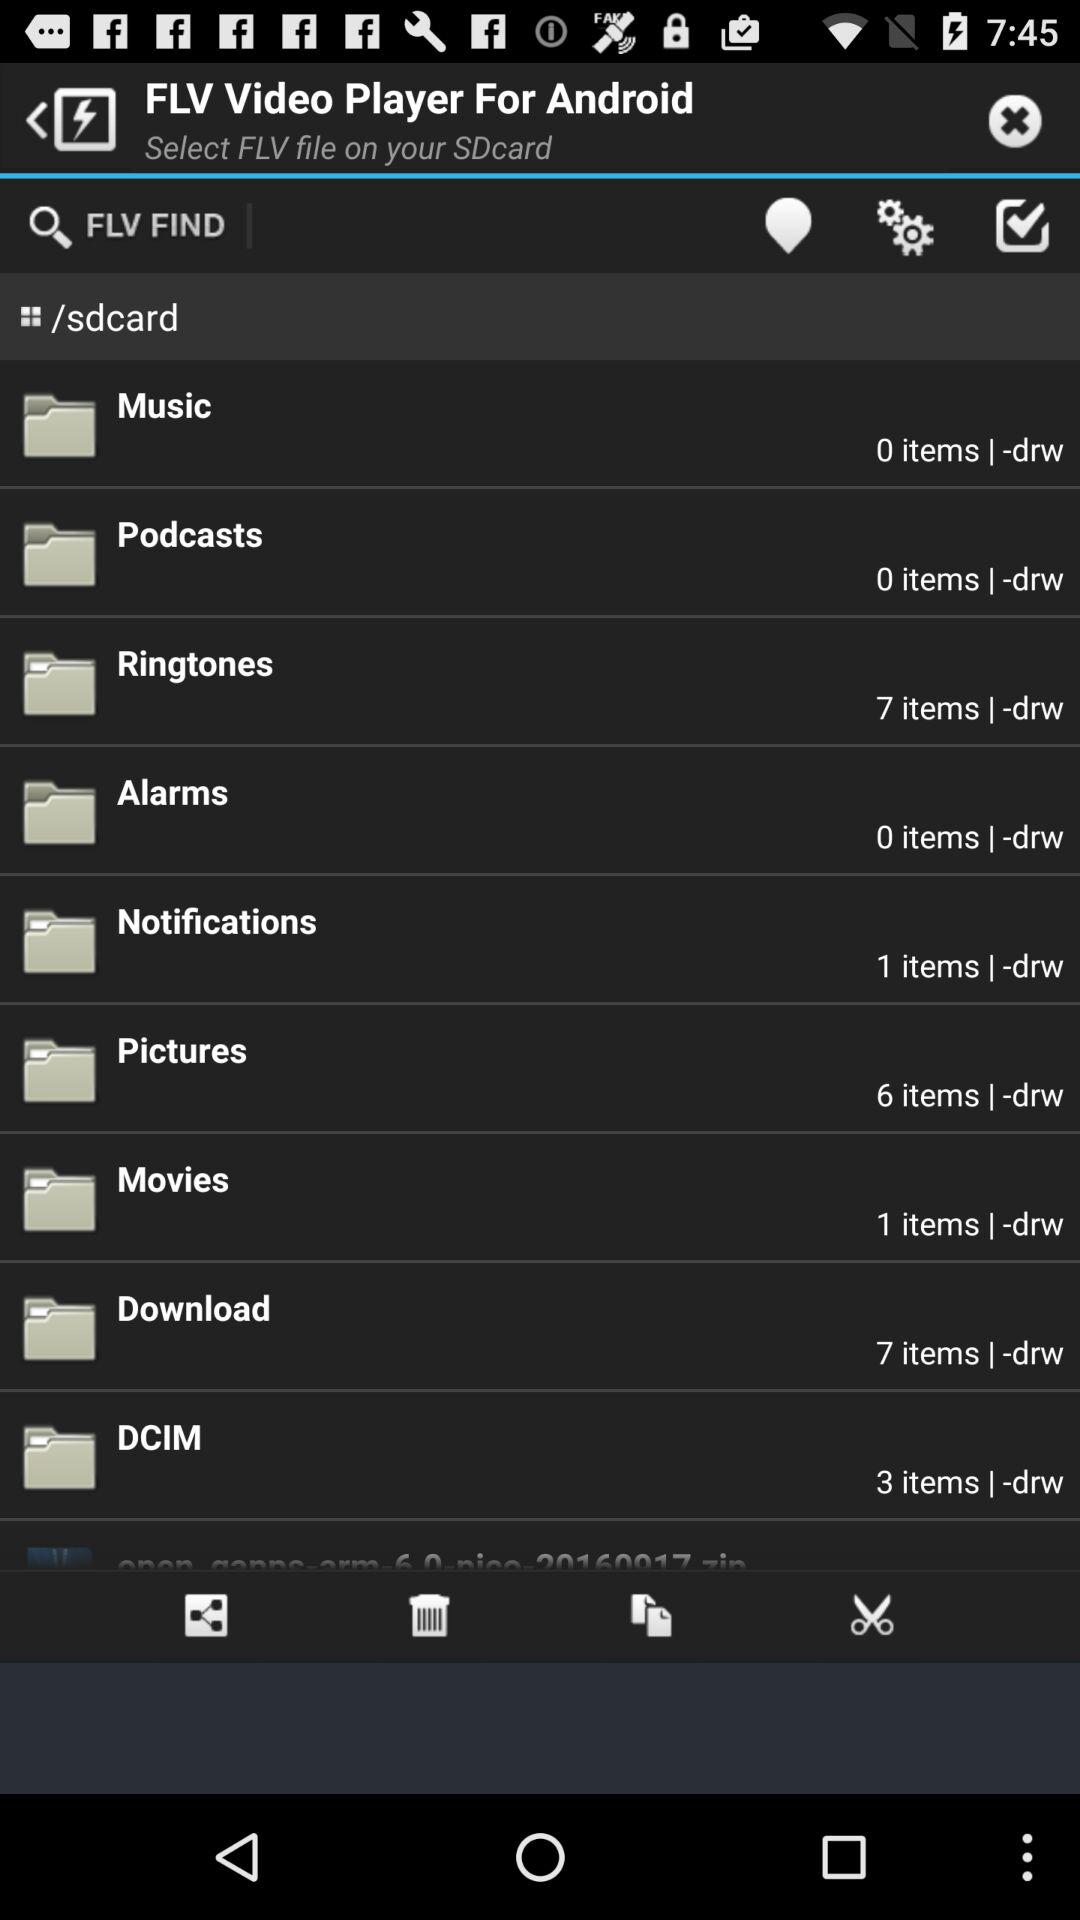Which folder has 0 items? The folders that have 0 items are "Music", "Podcasts" and "Alarms". 